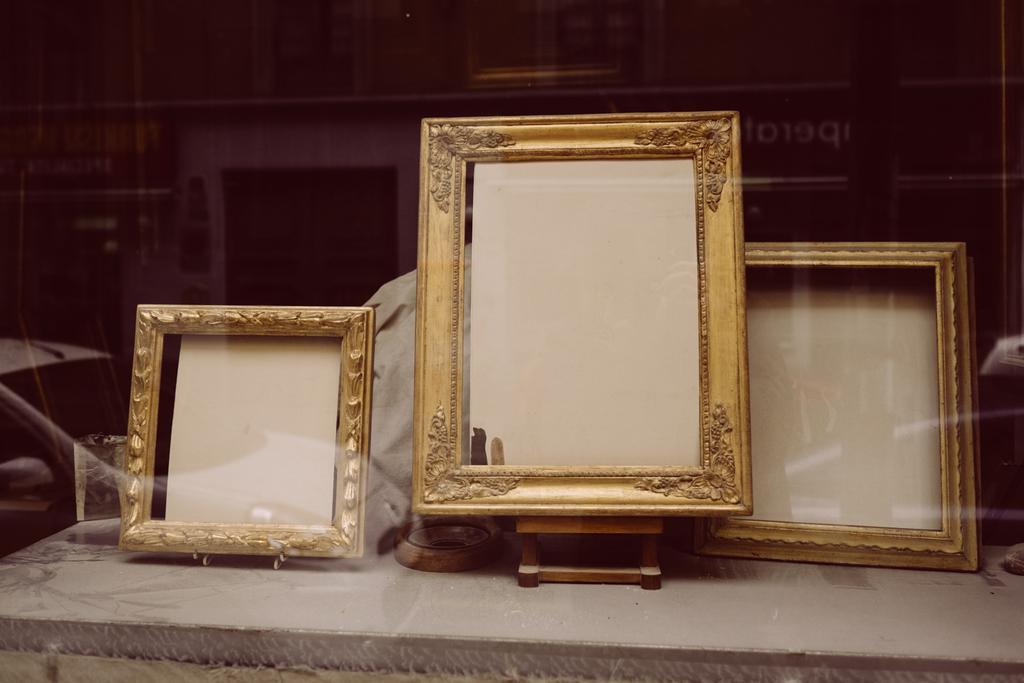Describe this image in one or two sentences. In the foreground of this image, there are three frames on a table and in the reflection of glass we can see buildings in the background. 